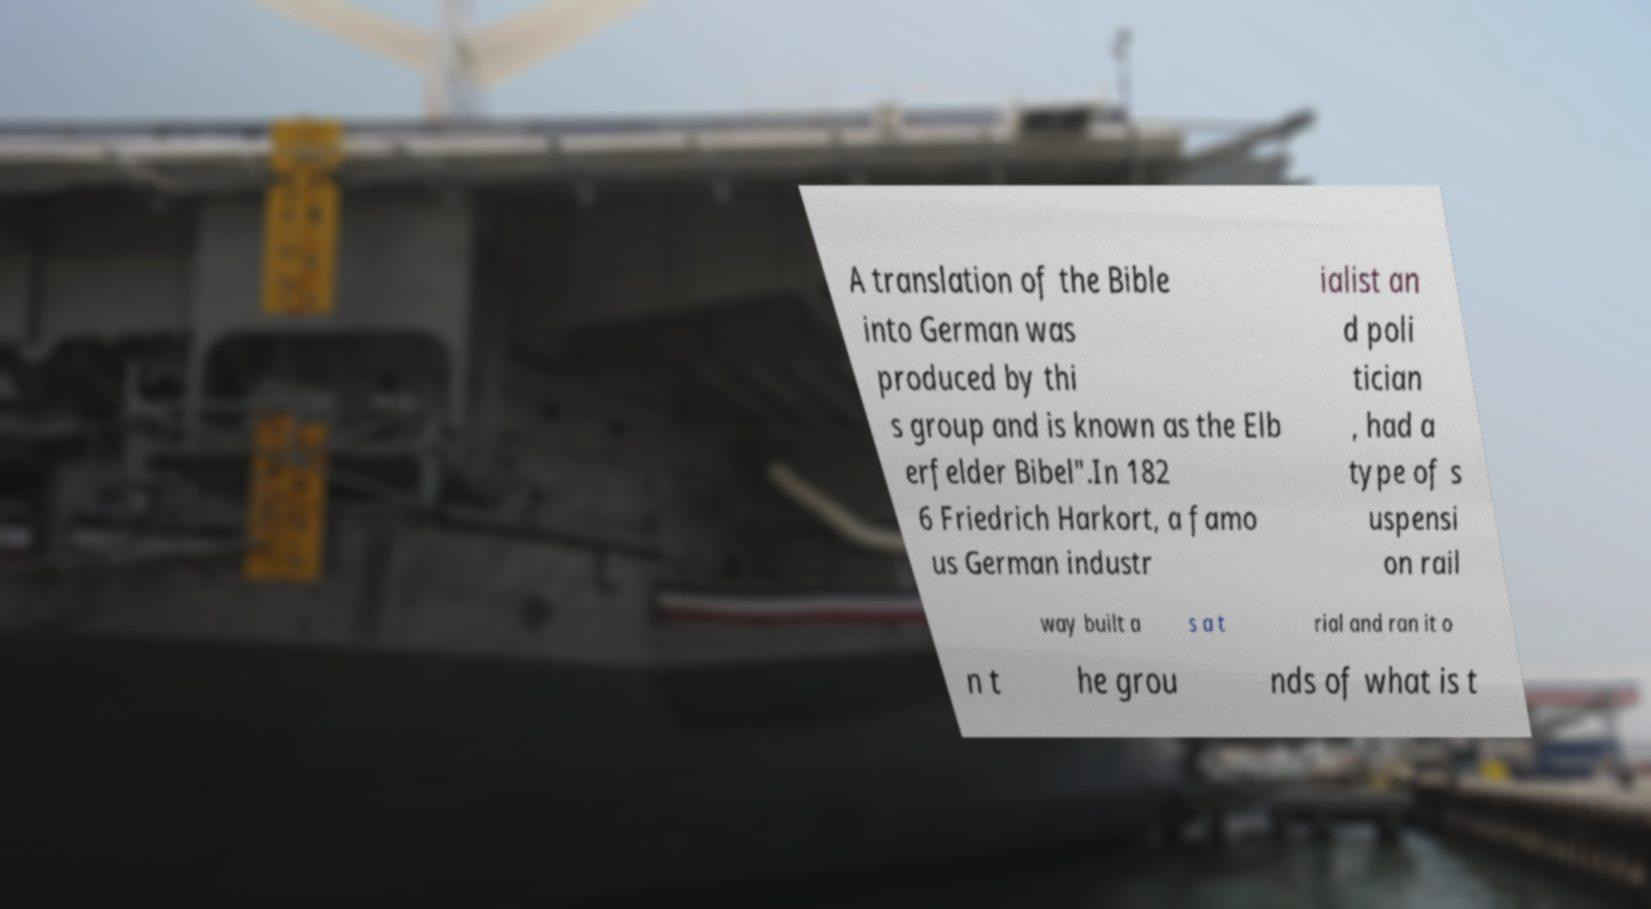What messages or text are displayed in this image? I need them in a readable, typed format. A translation of the Bible into German was produced by thi s group and is known as the Elb erfelder Bibel".In 182 6 Friedrich Harkort, a famo us German industr ialist an d poli tician , had a type of s uspensi on rail way built a s a t rial and ran it o n t he grou nds of what is t 